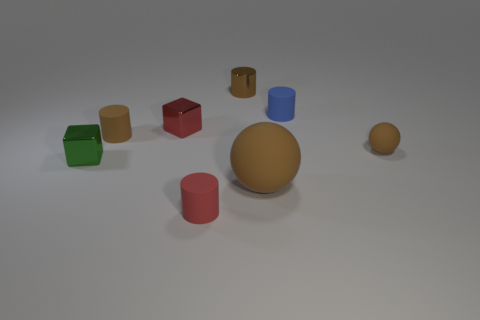What shape is the small red object that is made of the same material as the tiny green thing?
Offer a very short reply. Cube. What color is the cylinder that is left of the small blue rubber cylinder and behind the red block?
Offer a terse response. Brown. Does the sphere that is in front of the green object have the same material as the blue cylinder?
Give a very brief answer. Yes. Is the number of small brown cylinders that are on the left side of the brown metallic cylinder less than the number of shiny blocks?
Provide a short and direct response. Yes. Is there a small gray thing made of the same material as the tiny blue cylinder?
Provide a succinct answer. No. Does the brown metal cylinder have the same size as the shiny block that is behind the small brown rubber ball?
Ensure brevity in your answer.  Yes. Is there a big thing of the same color as the big rubber ball?
Provide a succinct answer. No. Are the blue object and the tiny red cylinder made of the same material?
Offer a very short reply. Yes. There is a red shiny object; how many tiny green shiny blocks are in front of it?
Your answer should be very brief. 1. There is a cylinder that is in front of the red shiny thing and behind the big brown sphere; what material is it?
Your response must be concise. Rubber. 